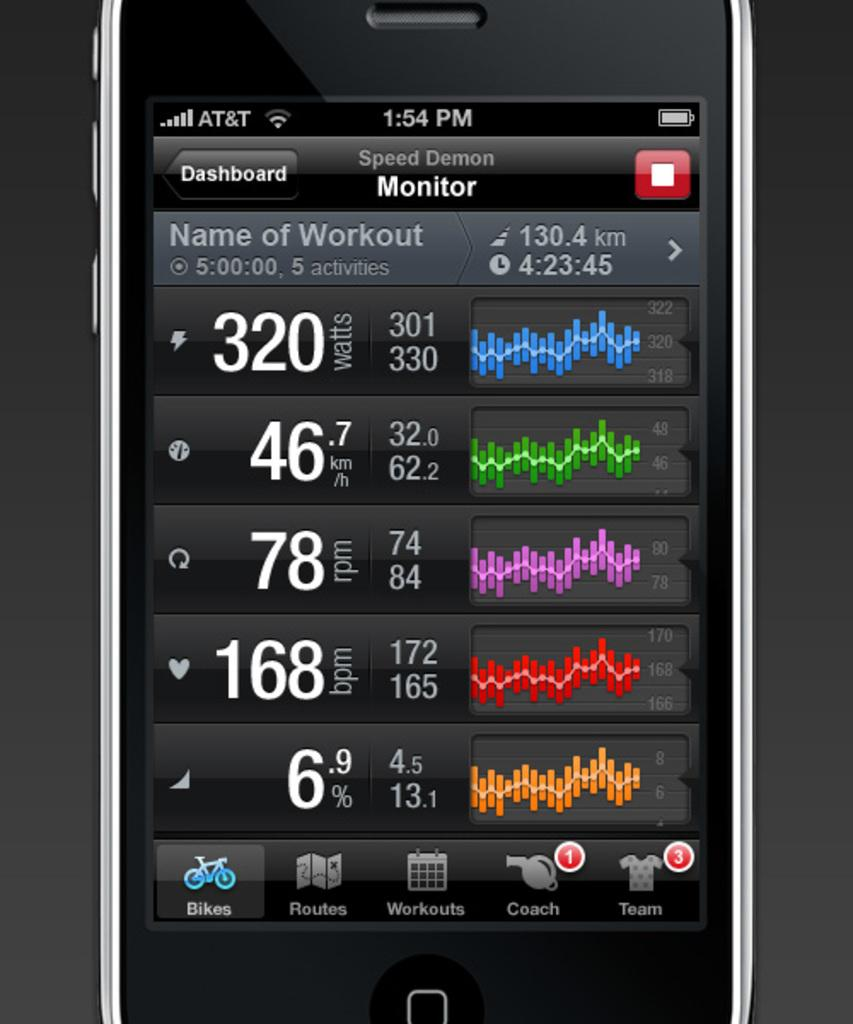<image>
Share a concise interpretation of the image provided. A phone is showing an app from Speed demon which monitor a person's workout. 